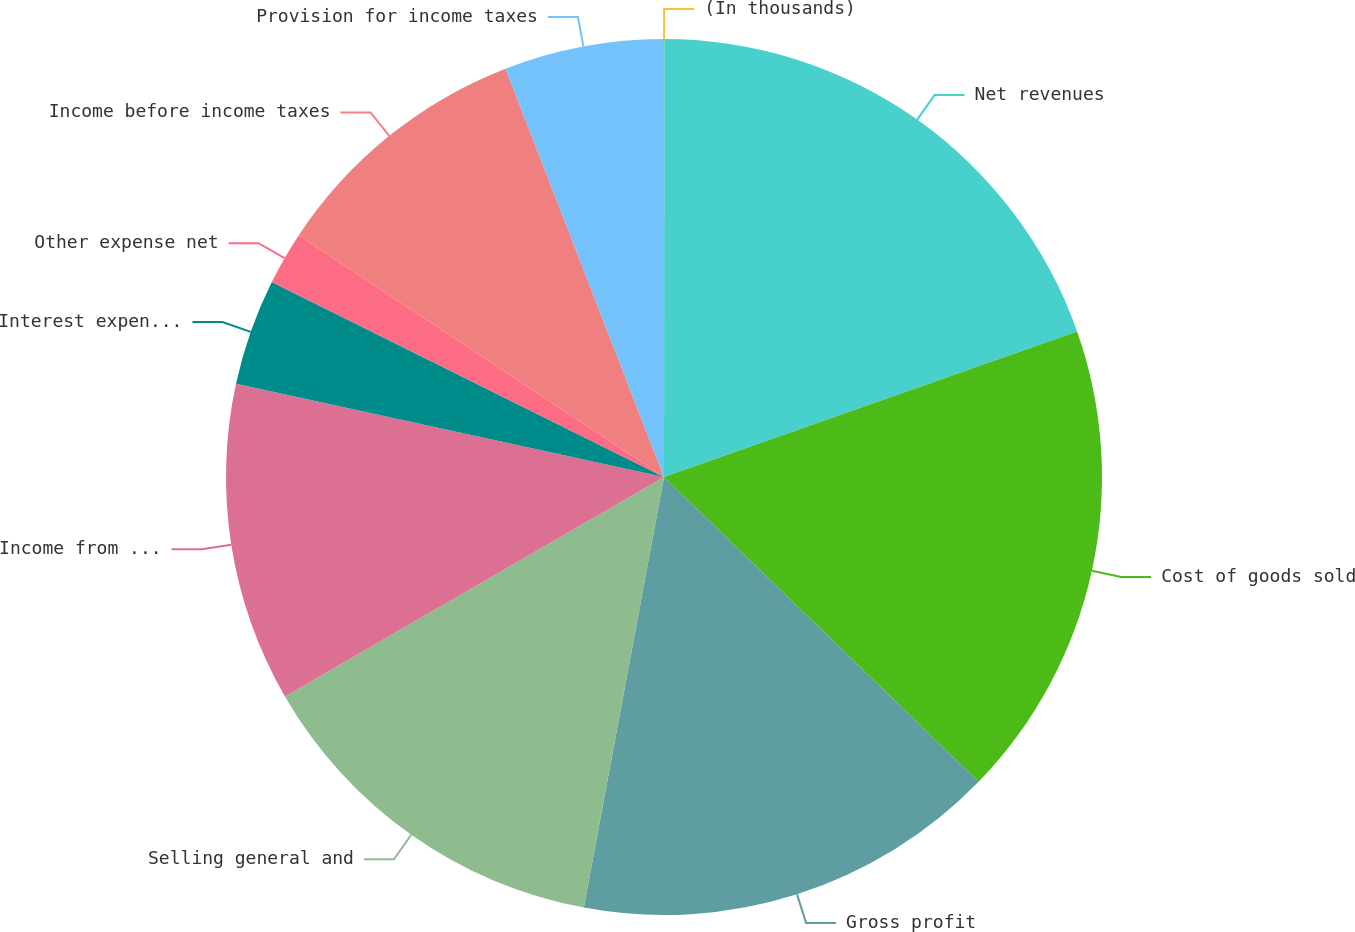Convert chart to OTSL. <chart><loc_0><loc_0><loc_500><loc_500><pie_chart><fcel>(In thousands)<fcel>Net revenues<fcel>Cost of goods sold<fcel>Gross profit<fcel>Selling general and<fcel>Income from operations<fcel>Interest expense net<fcel>Other expense net<fcel>Income before income taxes<fcel>Provision for income taxes<nl><fcel>0.01%<fcel>19.6%<fcel>17.64%<fcel>15.68%<fcel>13.72%<fcel>11.76%<fcel>3.93%<fcel>1.97%<fcel>9.8%<fcel>5.89%<nl></chart> 